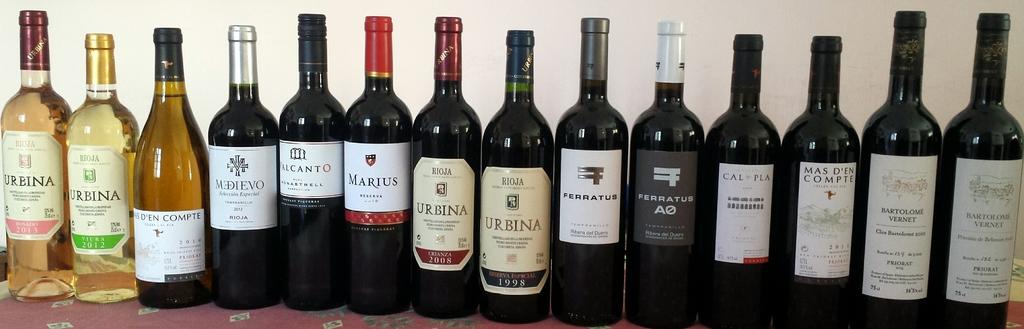What brand is the furthest left bottle of wine?
Provide a short and direct response. Urbina. What is the brand of wine with red packaging?
Keep it short and to the point. Marius. 